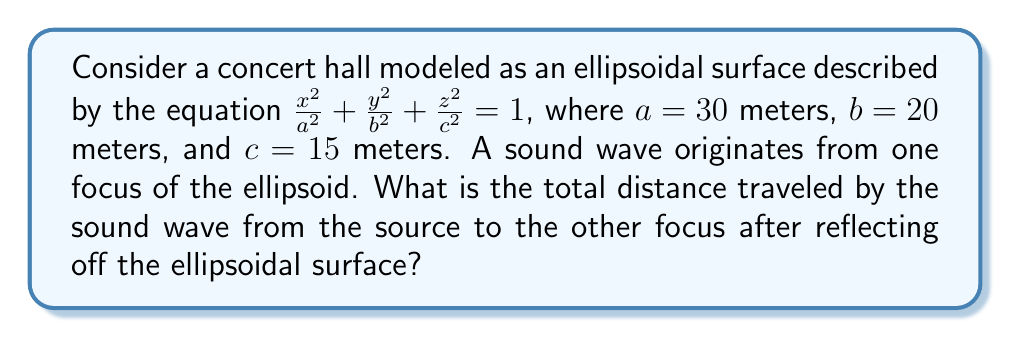Teach me how to tackle this problem. Let's approach this step-by-step:

1) In an ellipsoid, the sum of the distances from any point on the surface to the two foci is constant and equal to the major axis (2a).

2) The foci of an ellipsoid lie on its major axis. The distance of each focus from the center is given by:
   
   $$f = \sqrt{a^2 - b^2}$$

   Where $a > b > c$

3) In our case:
   $$f = \sqrt{30^2 - 20^2} = \sqrt{500} = 10\sqrt{5}$$ meters

4) The total distance traveled by the sound wave is twice the major axis (2a), as it travels from one focus to the surface and then to the other focus.

5) The major axis (2a) is 60 meters.

6) Therefore, the total distance traveled by the sound wave is:
   
   $$2(2a) = 2(60) = 120$$ meters

This result aligns with the principle of ellipsoidal reflectors in acoustics, where sound from one focus is perfectly reflected to the other focus, a concept a conductor would appreciate in understanding hall acoustics.
Answer: 120 meters 